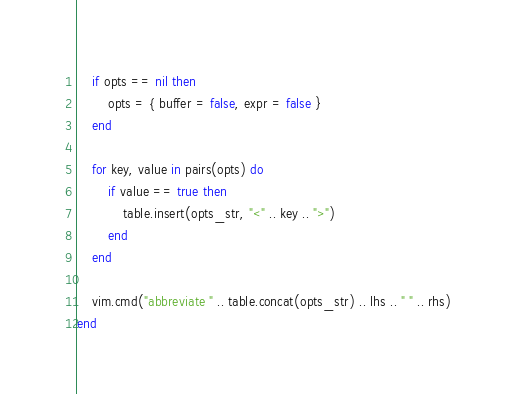Convert code to text. <code><loc_0><loc_0><loc_500><loc_500><_Lua_>    if opts == nil then
        opts = { buffer = false, expr = false }
    end

    for key, value in pairs(opts) do
        if value == true then
            table.insert(opts_str, "<" .. key .. ">")
        end
    end

    vim.cmd("abbreviate " .. table.concat(opts_str) .. lhs .. " " .. rhs)
end
</code> 